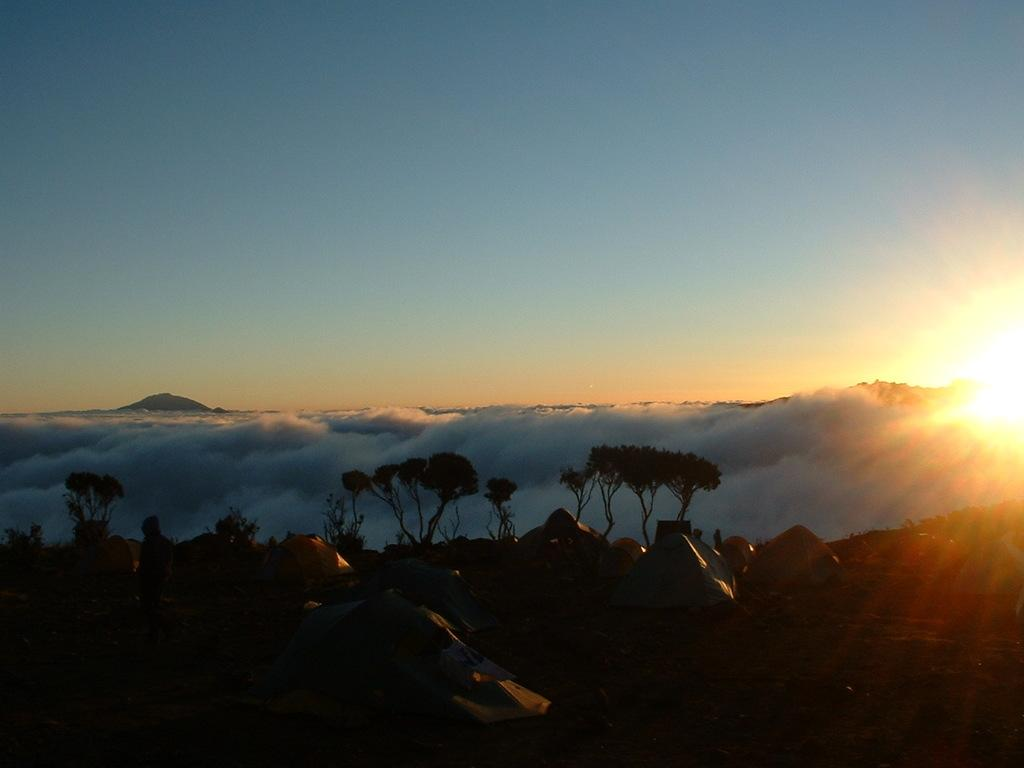What can be seen on the ground in the image? There are many tents on the ground in the image. Are there any other elements present on the ground besides the tents? There may be people present on the ground. What is located beside the tents? There are trees beside the tents. What is the weather like in the image? There is snow present in the image, and the sky is clear. How many crows can be seen in the image? There are no crows present in the image. What is the quietest way to sort the tents in the image? The image does not depict any sorting of tents, and the concept of quietness is not applicable to the image. 